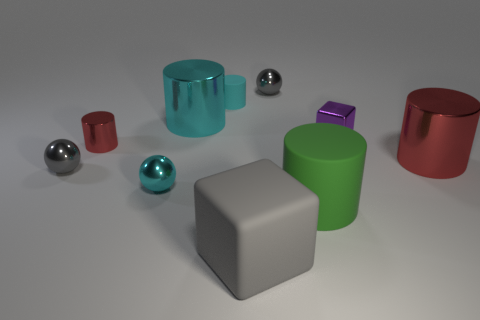How many rubber objects are purple things or tiny objects?
Keep it short and to the point. 1. Is there any other thing that has the same size as the green cylinder?
Your answer should be compact. Yes. There is a rubber thing that is on the right side of the small gray object that is behind the cyan shiny cylinder; what is its shape?
Your response must be concise. Cylinder. Is the big cylinder in front of the big red metallic cylinder made of the same material as the small gray object that is right of the big gray object?
Your answer should be very brief. No. There is a shiny cylinder on the right side of the big gray rubber block; how many small gray metal objects are on the right side of it?
Provide a short and direct response. 0. Is the shape of the small gray metallic thing that is behind the small cyan cylinder the same as the large thing behind the tiny purple cube?
Make the answer very short. No. What size is the gray object that is behind the big green rubber object and in front of the cyan rubber object?
Your answer should be compact. Small. There is another object that is the same shape as the tiny purple shiny thing; what color is it?
Your answer should be very brief. Gray. There is a matte cylinder that is behind the large matte object that is behind the large cube; what is its color?
Keep it short and to the point. Cyan. The big green rubber object has what shape?
Make the answer very short. Cylinder. 